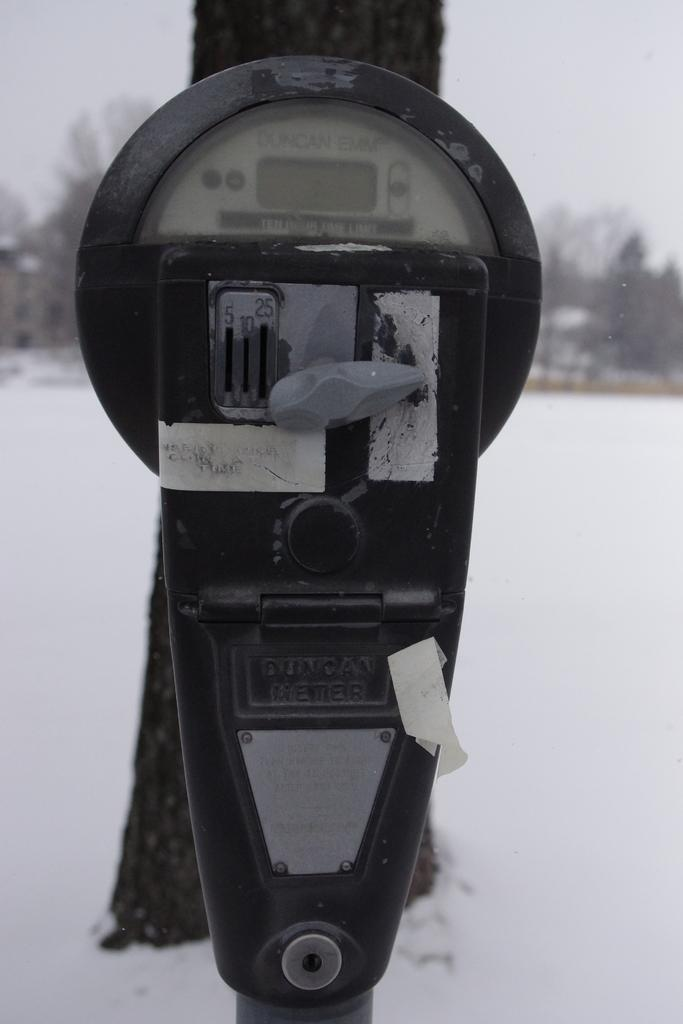Provide a one-sentence caption for the provided image. PARKING METER IN FRONT OF A TREE WITH SNOW ON THE GROUND. 